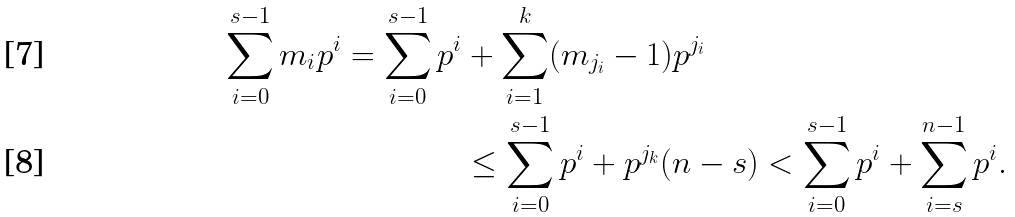<formula> <loc_0><loc_0><loc_500><loc_500>\sum _ { i = 0 } ^ { s - 1 } m _ { i } p ^ { i } = \sum _ { i = 0 } ^ { s - 1 } p ^ { i } & + \sum _ { i = 1 } ^ { k } ( m _ { j _ { i } } - 1 ) p ^ { j _ { i } } \\ & \leq \sum _ { i = 0 } ^ { s - 1 } p ^ { i } + p ^ { j _ { k } } ( n - s ) < \sum _ { i = 0 } ^ { s - 1 } p ^ { i } + \sum _ { i = s } ^ { n - 1 } p ^ { i } .</formula> 